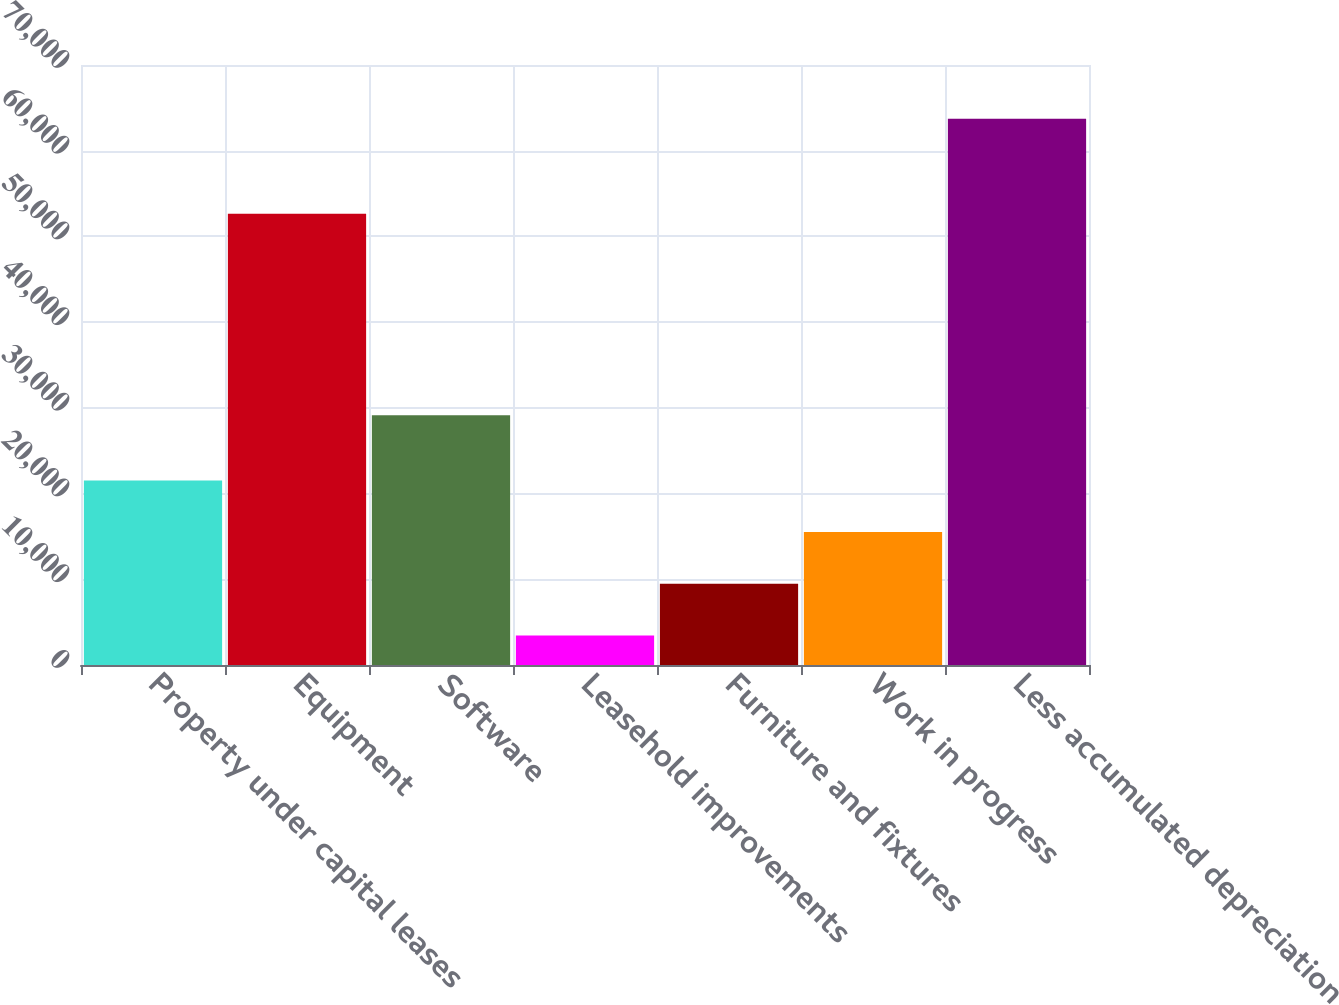Convert chart to OTSL. <chart><loc_0><loc_0><loc_500><loc_500><bar_chart><fcel>Property under capital leases<fcel>Equipment<fcel>Software<fcel>Leasehold improvements<fcel>Furniture and fixtures<fcel>Work in progress<fcel>Less accumulated depreciation<nl><fcel>21538<fcel>52652<fcel>29129<fcel>3451<fcel>9480<fcel>15509<fcel>63741<nl></chart> 